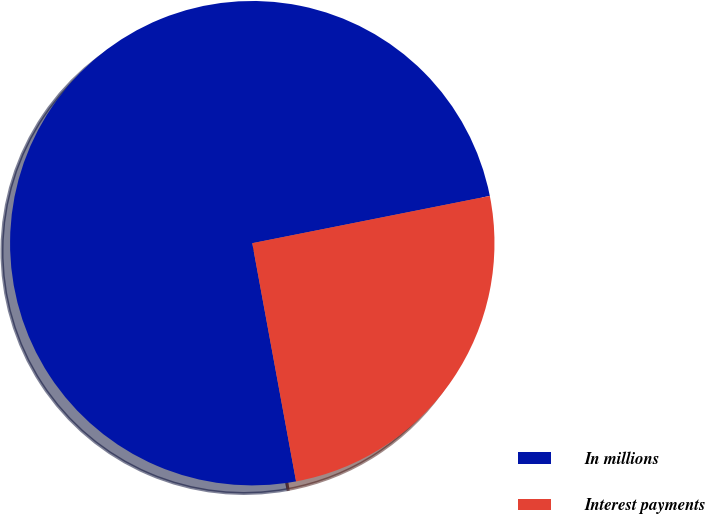<chart> <loc_0><loc_0><loc_500><loc_500><pie_chart><fcel>In millions<fcel>Interest payments<nl><fcel>74.77%<fcel>25.23%<nl></chart> 